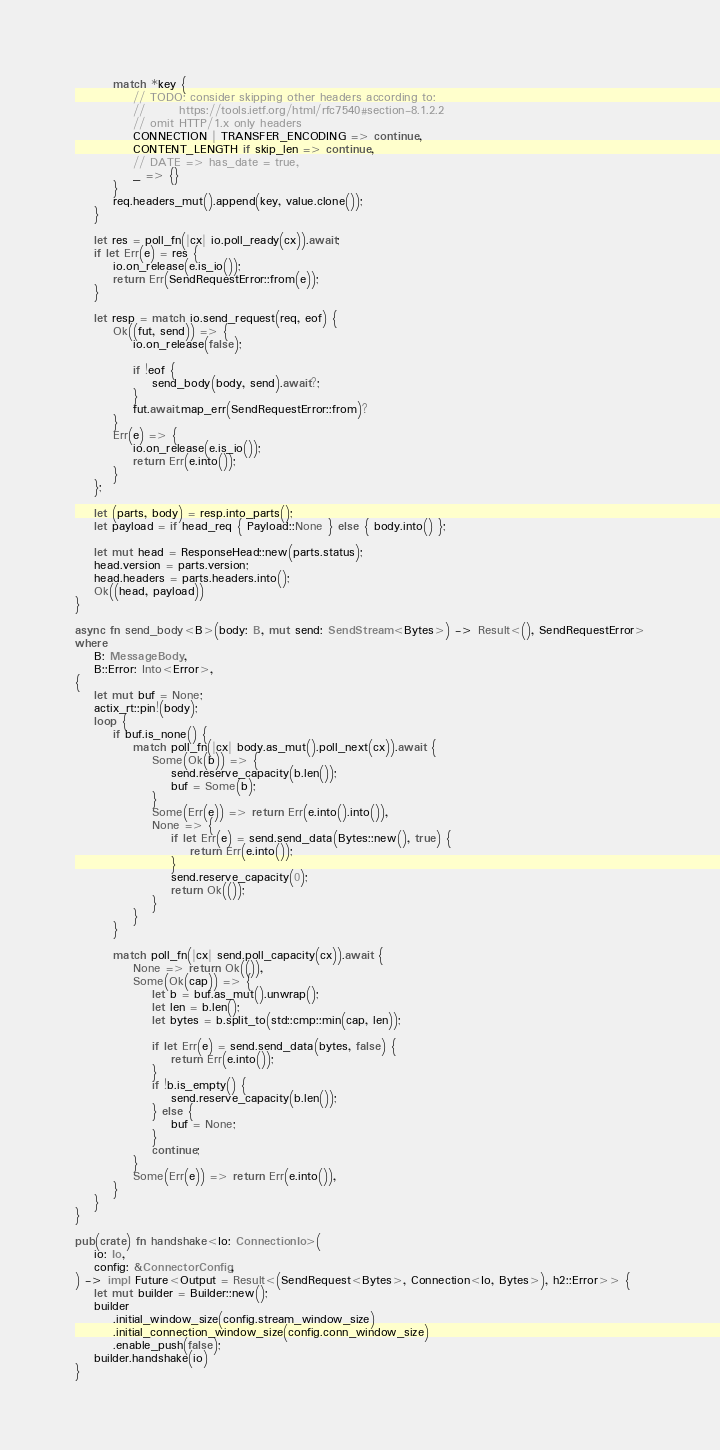<code> <loc_0><loc_0><loc_500><loc_500><_Rust_>        match *key {
            // TODO: consider skipping other headers according to:
            //       https://tools.ietf.org/html/rfc7540#section-8.1.2.2
            // omit HTTP/1.x only headers
            CONNECTION | TRANSFER_ENCODING => continue,
            CONTENT_LENGTH if skip_len => continue,
            // DATE => has_date = true,
            _ => {}
        }
        req.headers_mut().append(key, value.clone());
    }

    let res = poll_fn(|cx| io.poll_ready(cx)).await;
    if let Err(e) = res {
        io.on_release(e.is_io());
        return Err(SendRequestError::from(e));
    }

    let resp = match io.send_request(req, eof) {
        Ok((fut, send)) => {
            io.on_release(false);

            if !eof {
                send_body(body, send).await?;
            }
            fut.await.map_err(SendRequestError::from)?
        }
        Err(e) => {
            io.on_release(e.is_io());
            return Err(e.into());
        }
    };

    let (parts, body) = resp.into_parts();
    let payload = if head_req { Payload::None } else { body.into() };

    let mut head = ResponseHead::new(parts.status);
    head.version = parts.version;
    head.headers = parts.headers.into();
    Ok((head, payload))
}

async fn send_body<B>(body: B, mut send: SendStream<Bytes>) -> Result<(), SendRequestError>
where
    B: MessageBody,
    B::Error: Into<Error>,
{
    let mut buf = None;
    actix_rt::pin!(body);
    loop {
        if buf.is_none() {
            match poll_fn(|cx| body.as_mut().poll_next(cx)).await {
                Some(Ok(b)) => {
                    send.reserve_capacity(b.len());
                    buf = Some(b);
                }
                Some(Err(e)) => return Err(e.into().into()),
                None => {
                    if let Err(e) = send.send_data(Bytes::new(), true) {
                        return Err(e.into());
                    }
                    send.reserve_capacity(0);
                    return Ok(());
                }
            }
        }

        match poll_fn(|cx| send.poll_capacity(cx)).await {
            None => return Ok(()),
            Some(Ok(cap)) => {
                let b = buf.as_mut().unwrap();
                let len = b.len();
                let bytes = b.split_to(std::cmp::min(cap, len));

                if let Err(e) = send.send_data(bytes, false) {
                    return Err(e.into());
                }
                if !b.is_empty() {
                    send.reserve_capacity(b.len());
                } else {
                    buf = None;
                }
                continue;
            }
            Some(Err(e)) => return Err(e.into()),
        }
    }
}

pub(crate) fn handshake<Io: ConnectionIo>(
    io: Io,
    config: &ConnectorConfig,
) -> impl Future<Output = Result<(SendRequest<Bytes>, Connection<Io, Bytes>), h2::Error>> {
    let mut builder = Builder::new();
    builder
        .initial_window_size(config.stream_window_size)
        .initial_connection_window_size(config.conn_window_size)
        .enable_push(false);
    builder.handshake(io)
}
</code> 